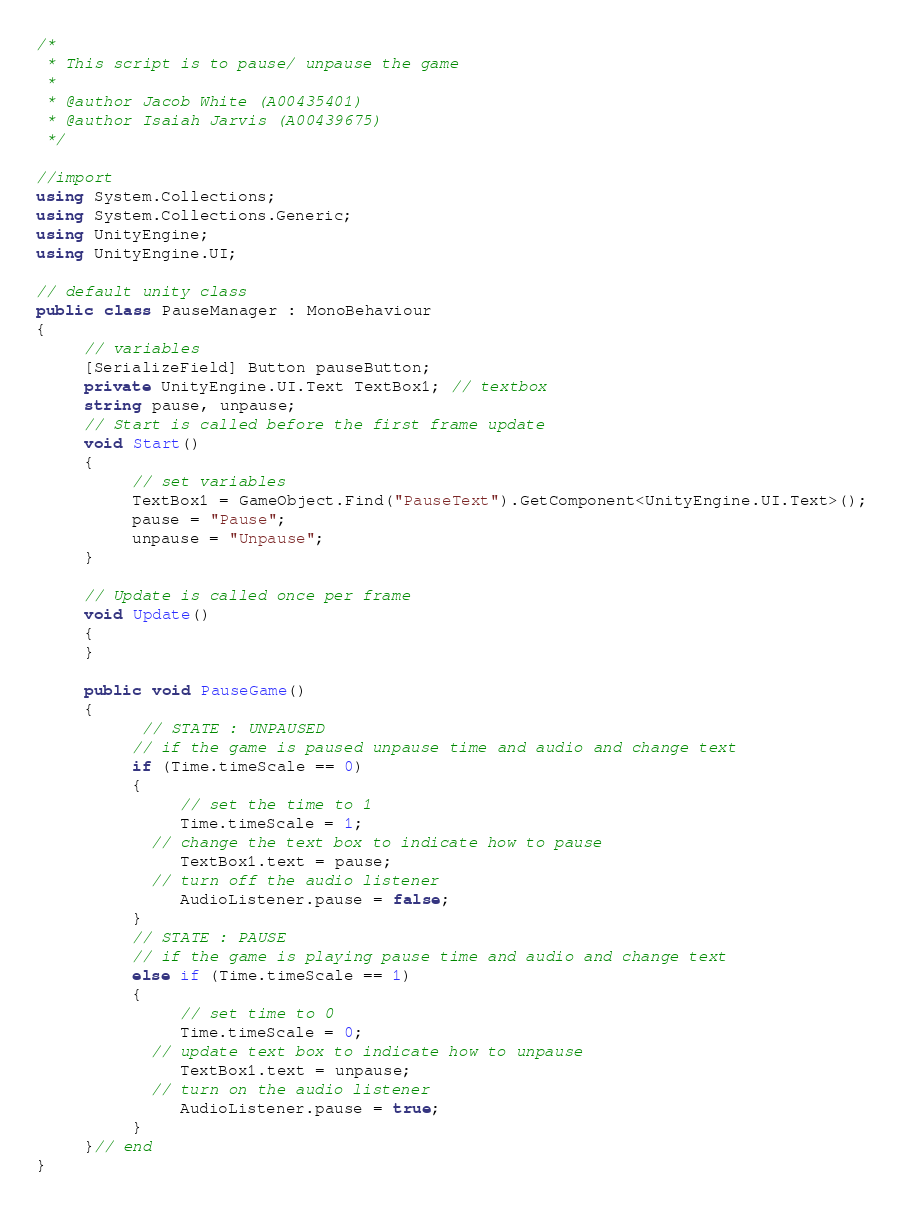<code> <loc_0><loc_0><loc_500><loc_500><_C#_>/*
 * This script is to pause/ unpause the game
 * 
 * @author Jacob White (A00435401)
 * @author Isaiah Jarvis (A00439675)
 */

//import
using System.Collections;
using System.Collections.Generic;
using UnityEngine;
using UnityEngine.UI;

// default unity class
public class PauseManager : MonoBehaviour
{
     // variables
     [SerializeField] Button pauseButton;
     private UnityEngine.UI.Text TextBox1; // textbox
     string pause, unpause;
     // Start is called before the first frame update
     void Start()
     {
          // set variables
          TextBox1 = GameObject.Find("PauseText").GetComponent<UnityEngine.UI.Text>();
          pause = "Pause";
          unpause = "Unpause";
     }

     // Update is called once per frame
     void Update()
     {
     }

     public void PauseGame()
     {
           // STATE : UNPAUSED
          // if the game is paused unpause time and audio and change text
          if (Time.timeScale == 0)
          {
               // set the time to 1
               Time.timeScale = 1;
            // change the text box to indicate how to pause
               TextBox1.text = pause;
            // turn off the audio listener 
               AudioListener.pause = false;
          }
          // STATE : PAUSE
          // if the game is playing pause time and audio and change text
          else if (Time.timeScale == 1)
          {
               // set time to 0
               Time.timeScale = 0;
            // update text box to indicate how to unpause
               TextBox1.text = unpause;
            // turn on the audio listener
               AudioListener.pause = true;
          }
     }// end
}</code> 